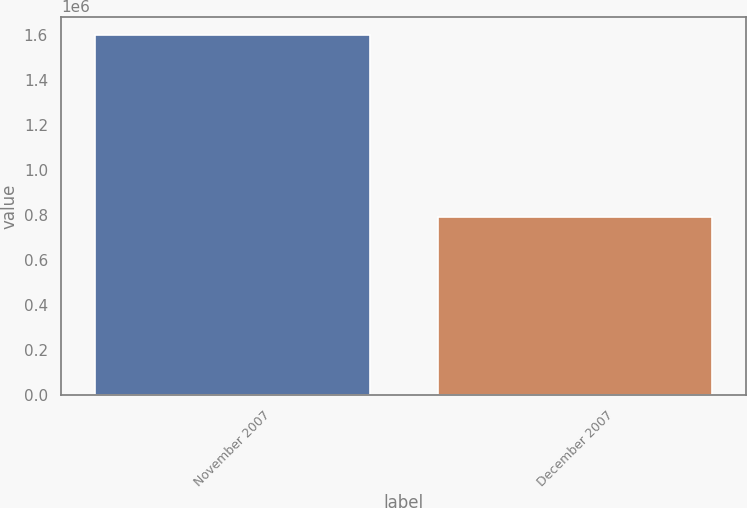Convert chart to OTSL. <chart><loc_0><loc_0><loc_500><loc_500><bar_chart><fcel>November 2007<fcel>December 2007<nl><fcel>1.6e+06<fcel>790000<nl></chart> 